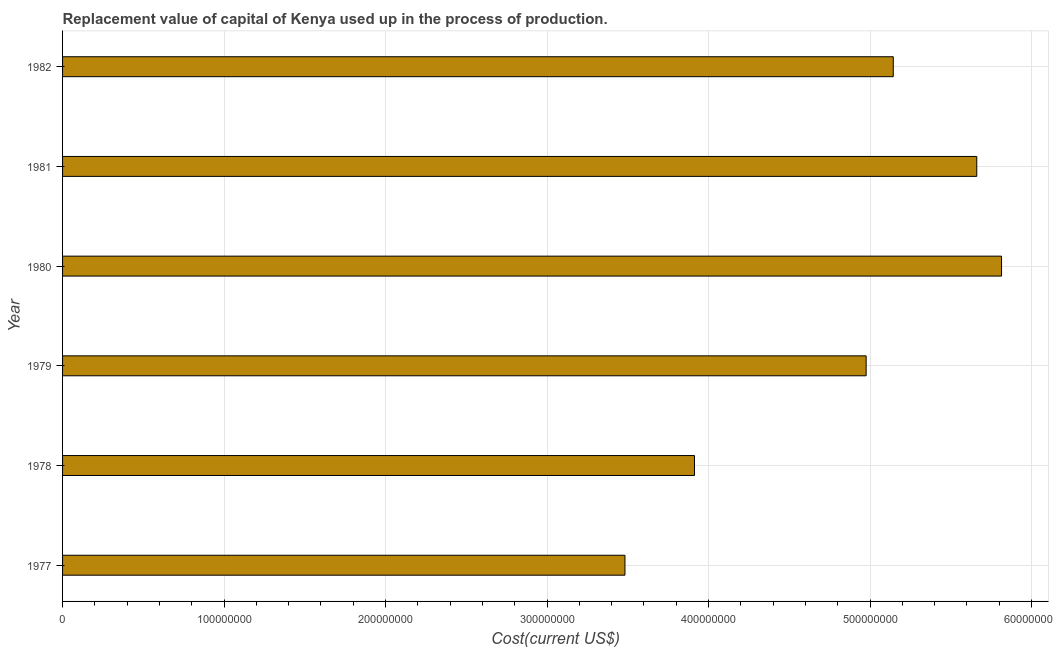Does the graph contain any zero values?
Provide a short and direct response. No. What is the title of the graph?
Your response must be concise. Replacement value of capital of Kenya used up in the process of production. What is the label or title of the X-axis?
Your answer should be compact. Cost(current US$). What is the consumption of fixed capital in 1979?
Your answer should be very brief. 4.98e+08. Across all years, what is the maximum consumption of fixed capital?
Keep it short and to the point. 5.81e+08. Across all years, what is the minimum consumption of fixed capital?
Offer a terse response. 3.48e+08. In which year was the consumption of fixed capital maximum?
Give a very brief answer. 1980. What is the sum of the consumption of fixed capital?
Your answer should be very brief. 2.90e+09. What is the difference between the consumption of fixed capital in 1977 and 1980?
Your answer should be compact. -2.33e+08. What is the average consumption of fixed capital per year?
Your answer should be very brief. 4.83e+08. What is the median consumption of fixed capital?
Ensure brevity in your answer.  5.06e+08. Is the consumption of fixed capital in 1978 less than that in 1980?
Make the answer very short. Yes. What is the difference between the highest and the second highest consumption of fixed capital?
Your answer should be very brief. 1.53e+07. Is the sum of the consumption of fixed capital in 1980 and 1982 greater than the maximum consumption of fixed capital across all years?
Provide a succinct answer. Yes. What is the difference between the highest and the lowest consumption of fixed capital?
Ensure brevity in your answer.  2.33e+08. How many bars are there?
Give a very brief answer. 6. Are all the bars in the graph horizontal?
Provide a succinct answer. Yes. What is the difference between two consecutive major ticks on the X-axis?
Provide a short and direct response. 1.00e+08. What is the Cost(current US$) of 1977?
Keep it short and to the point. 3.48e+08. What is the Cost(current US$) in 1978?
Offer a very short reply. 3.91e+08. What is the Cost(current US$) of 1979?
Ensure brevity in your answer.  4.98e+08. What is the Cost(current US$) of 1980?
Give a very brief answer. 5.81e+08. What is the Cost(current US$) of 1981?
Keep it short and to the point. 5.66e+08. What is the Cost(current US$) of 1982?
Your response must be concise. 5.14e+08. What is the difference between the Cost(current US$) in 1977 and 1978?
Provide a short and direct response. -4.30e+07. What is the difference between the Cost(current US$) in 1977 and 1979?
Your answer should be compact. -1.49e+08. What is the difference between the Cost(current US$) in 1977 and 1980?
Give a very brief answer. -2.33e+08. What is the difference between the Cost(current US$) in 1977 and 1981?
Your answer should be very brief. -2.18e+08. What is the difference between the Cost(current US$) in 1977 and 1982?
Your response must be concise. -1.66e+08. What is the difference between the Cost(current US$) in 1978 and 1979?
Your response must be concise. -1.06e+08. What is the difference between the Cost(current US$) in 1978 and 1980?
Offer a very short reply. -1.90e+08. What is the difference between the Cost(current US$) in 1978 and 1981?
Give a very brief answer. -1.75e+08. What is the difference between the Cost(current US$) in 1978 and 1982?
Ensure brevity in your answer.  -1.23e+08. What is the difference between the Cost(current US$) in 1979 and 1980?
Offer a very short reply. -8.38e+07. What is the difference between the Cost(current US$) in 1979 and 1981?
Keep it short and to the point. -6.85e+07. What is the difference between the Cost(current US$) in 1979 and 1982?
Your answer should be very brief. -1.68e+07. What is the difference between the Cost(current US$) in 1980 and 1981?
Provide a succinct answer. 1.53e+07. What is the difference between the Cost(current US$) in 1980 and 1982?
Keep it short and to the point. 6.70e+07. What is the difference between the Cost(current US$) in 1981 and 1982?
Ensure brevity in your answer.  5.17e+07. What is the ratio of the Cost(current US$) in 1977 to that in 1978?
Keep it short and to the point. 0.89. What is the ratio of the Cost(current US$) in 1977 to that in 1980?
Your answer should be compact. 0.6. What is the ratio of the Cost(current US$) in 1977 to that in 1981?
Your response must be concise. 0.61. What is the ratio of the Cost(current US$) in 1977 to that in 1982?
Your response must be concise. 0.68. What is the ratio of the Cost(current US$) in 1978 to that in 1979?
Offer a very short reply. 0.79. What is the ratio of the Cost(current US$) in 1978 to that in 1980?
Your response must be concise. 0.67. What is the ratio of the Cost(current US$) in 1978 to that in 1981?
Provide a short and direct response. 0.69. What is the ratio of the Cost(current US$) in 1978 to that in 1982?
Keep it short and to the point. 0.76. What is the ratio of the Cost(current US$) in 1979 to that in 1980?
Your response must be concise. 0.86. What is the ratio of the Cost(current US$) in 1979 to that in 1981?
Your answer should be very brief. 0.88. What is the ratio of the Cost(current US$) in 1980 to that in 1982?
Keep it short and to the point. 1.13. What is the ratio of the Cost(current US$) in 1981 to that in 1982?
Provide a short and direct response. 1.1. 